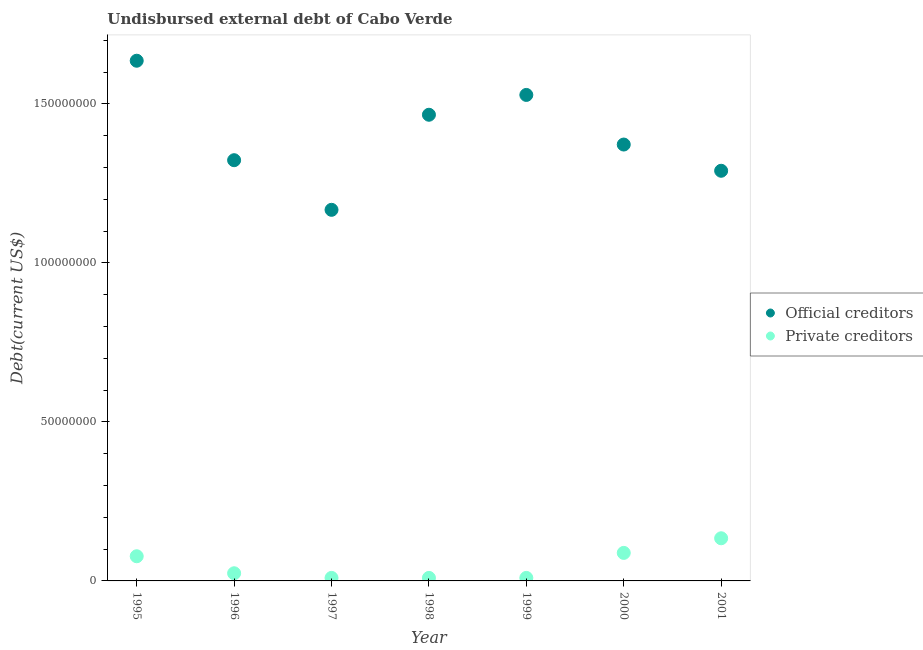How many different coloured dotlines are there?
Keep it short and to the point. 2. Is the number of dotlines equal to the number of legend labels?
Make the answer very short. Yes. What is the undisbursed external debt of official creditors in 1997?
Ensure brevity in your answer.  1.17e+08. Across all years, what is the maximum undisbursed external debt of official creditors?
Give a very brief answer. 1.64e+08. Across all years, what is the minimum undisbursed external debt of official creditors?
Offer a terse response. 1.17e+08. In which year was the undisbursed external debt of official creditors maximum?
Keep it short and to the point. 1995. What is the total undisbursed external debt of private creditors in the graph?
Your answer should be compact. 3.52e+07. What is the difference between the undisbursed external debt of official creditors in 1996 and that in 1997?
Offer a terse response. 1.56e+07. What is the difference between the undisbursed external debt of official creditors in 1997 and the undisbursed external debt of private creditors in 1996?
Your response must be concise. 1.14e+08. What is the average undisbursed external debt of official creditors per year?
Keep it short and to the point. 1.40e+08. In the year 2001, what is the difference between the undisbursed external debt of official creditors and undisbursed external debt of private creditors?
Your answer should be very brief. 1.16e+08. What is the ratio of the undisbursed external debt of official creditors in 1997 to that in 2001?
Offer a terse response. 0.9. Is the difference between the undisbursed external debt of private creditors in 1996 and 1997 greater than the difference between the undisbursed external debt of official creditors in 1996 and 1997?
Ensure brevity in your answer.  No. What is the difference between the highest and the second highest undisbursed external debt of private creditors?
Offer a very short reply. 4.60e+06. What is the difference between the highest and the lowest undisbursed external debt of private creditors?
Give a very brief answer. 1.25e+07. In how many years, is the undisbursed external debt of private creditors greater than the average undisbursed external debt of private creditors taken over all years?
Keep it short and to the point. 3. Is the sum of the undisbursed external debt of private creditors in 1999 and 2000 greater than the maximum undisbursed external debt of official creditors across all years?
Your answer should be compact. No. Does the undisbursed external debt of official creditors monotonically increase over the years?
Your response must be concise. No. Is the undisbursed external debt of official creditors strictly less than the undisbursed external debt of private creditors over the years?
Offer a very short reply. No. How many dotlines are there?
Ensure brevity in your answer.  2. How many years are there in the graph?
Offer a very short reply. 7. Are the values on the major ticks of Y-axis written in scientific E-notation?
Keep it short and to the point. No. What is the title of the graph?
Provide a short and direct response. Undisbursed external debt of Cabo Verde. What is the label or title of the Y-axis?
Keep it short and to the point. Debt(current US$). What is the Debt(current US$) in Official creditors in 1995?
Keep it short and to the point. 1.64e+08. What is the Debt(current US$) of Private creditors in 1995?
Your answer should be compact. 7.76e+06. What is the Debt(current US$) in Official creditors in 1996?
Provide a succinct answer. 1.32e+08. What is the Debt(current US$) in Private creditors in 1996?
Keep it short and to the point. 2.41e+06. What is the Debt(current US$) of Official creditors in 1997?
Your answer should be very brief. 1.17e+08. What is the Debt(current US$) of Private creditors in 1997?
Ensure brevity in your answer.  9.48e+05. What is the Debt(current US$) in Official creditors in 1998?
Offer a very short reply. 1.47e+08. What is the Debt(current US$) of Private creditors in 1998?
Your answer should be very brief. 9.48e+05. What is the Debt(current US$) of Official creditors in 1999?
Your answer should be very brief. 1.53e+08. What is the Debt(current US$) in Private creditors in 1999?
Provide a succinct answer. 9.48e+05. What is the Debt(current US$) of Official creditors in 2000?
Your answer should be very brief. 1.37e+08. What is the Debt(current US$) of Private creditors in 2000?
Ensure brevity in your answer.  8.81e+06. What is the Debt(current US$) of Official creditors in 2001?
Offer a very short reply. 1.29e+08. What is the Debt(current US$) of Private creditors in 2001?
Provide a short and direct response. 1.34e+07. Across all years, what is the maximum Debt(current US$) in Official creditors?
Ensure brevity in your answer.  1.64e+08. Across all years, what is the maximum Debt(current US$) in Private creditors?
Your answer should be very brief. 1.34e+07. Across all years, what is the minimum Debt(current US$) in Official creditors?
Your answer should be very brief. 1.17e+08. Across all years, what is the minimum Debt(current US$) in Private creditors?
Make the answer very short. 9.48e+05. What is the total Debt(current US$) of Official creditors in the graph?
Your response must be concise. 9.78e+08. What is the total Debt(current US$) of Private creditors in the graph?
Give a very brief answer. 3.52e+07. What is the difference between the Debt(current US$) of Official creditors in 1995 and that in 1996?
Offer a terse response. 3.13e+07. What is the difference between the Debt(current US$) of Private creditors in 1995 and that in 1996?
Offer a terse response. 5.35e+06. What is the difference between the Debt(current US$) of Official creditors in 1995 and that in 1997?
Ensure brevity in your answer.  4.69e+07. What is the difference between the Debt(current US$) of Private creditors in 1995 and that in 1997?
Your response must be concise. 6.81e+06. What is the difference between the Debt(current US$) of Official creditors in 1995 and that in 1998?
Offer a very short reply. 1.70e+07. What is the difference between the Debt(current US$) in Private creditors in 1995 and that in 1998?
Give a very brief answer. 6.81e+06. What is the difference between the Debt(current US$) of Official creditors in 1995 and that in 1999?
Offer a terse response. 1.08e+07. What is the difference between the Debt(current US$) of Private creditors in 1995 and that in 1999?
Provide a succinct answer. 6.81e+06. What is the difference between the Debt(current US$) of Official creditors in 1995 and that in 2000?
Offer a very short reply. 2.64e+07. What is the difference between the Debt(current US$) in Private creditors in 1995 and that in 2000?
Give a very brief answer. -1.06e+06. What is the difference between the Debt(current US$) of Official creditors in 1995 and that in 2001?
Offer a very short reply. 3.46e+07. What is the difference between the Debt(current US$) of Private creditors in 1995 and that in 2001?
Your response must be concise. -5.66e+06. What is the difference between the Debt(current US$) of Official creditors in 1996 and that in 1997?
Your answer should be very brief. 1.56e+07. What is the difference between the Debt(current US$) of Private creditors in 1996 and that in 1997?
Give a very brief answer. 1.46e+06. What is the difference between the Debt(current US$) in Official creditors in 1996 and that in 1998?
Provide a succinct answer. -1.43e+07. What is the difference between the Debt(current US$) of Private creditors in 1996 and that in 1998?
Provide a succinct answer. 1.46e+06. What is the difference between the Debt(current US$) in Official creditors in 1996 and that in 1999?
Give a very brief answer. -2.05e+07. What is the difference between the Debt(current US$) in Private creditors in 1996 and that in 1999?
Give a very brief answer. 1.46e+06. What is the difference between the Debt(current US$) in Official creditors in 1996 and that in 2000?
Offer a terse response. -4.92e+06. What is the difference between the Debt(current US$) in Private creditors in 1996 and that in 2000?
Give a very brief answer. -6.40e+06. What is the difference between the Debt(current US$) in Official creditors in 1996 and that in 2001?
Your response must be concise. 3.32e+06. What is the difference between the Debt(current US$) in Private creditors in 1996 and that in 2001?
Your response must be concise. -1.10e+07. What is the difference between the Debt(current US$) in Official creditors in 1997 and that in 1998?
Offer a very short reply. -2.99e+07. What is the difference between the Debt(current US$) of Private creditors in 1997 and that in 1998?
Your answer should be compact. 0. What is the difference between the Debt(current US$) of Official creditors in 1997 and that in 1999?
Ensure brevity in your answer.  -3.61e+07. What is the difference between the Debt(current US$) of Official creditors in 1997 and that in 2000?
Make the answer very short. -2.05e+07. What is the difference between the Debt(current US$) of Private creditors in 1997 and that in 2000?
Offer a very short reply. -7.86e+06. What is the difference between the Debt(current US$) of Official creditors in 1997 and that in 2001?
Provide a short and direct response. -1.23e+07. What is the difference between the Debt(current US$) of Private creditors in 1997 and that in 2001?
Offer a very short reply. -1.25e+07. What is the difference between the Debt(current US$) of Official creditors in 1998 and that in 1999?
Your answer should be compact. -6.23e+06. What is the difference between the Debt(current US$) in Official creditors in 1998 and that in 2000?
Offer a very short reply. 9.37e+06. What is the difference between the Debt(current US$) of Private creditors in 1998 and that in 2000?
Give a very brief answer. -7.86e+06. What is the difference between the Debt(current US$) of Official creditors in 1998 and that in 2001?
Your answer should be compact. 1.76e+07. What is the difference between the Debt(current US$) of Private creditors in 1998 and that in 2001?
Keep it short and to the point. -1.25e+07. What is the difference between the Debt(current US$) in Official creditors in 1999 and that in 2000?
Keep it short and to the point. 1.56e+07. What is the difference between the Debt(current US$) in Private creditors in 1999 and that in 2000?
Keep it short and to the point. -7.86e+06. What is the difference between the Debt(current US$) in Official creditors in 1999 and that in 2001?
Ensure brevity in your answer.  2.38e+07. What is the difference between the Debt(current US$) of Private creditors in 1999 and that in 2001?
Provide a short and direct response. -1.25e+07. What is the difference between the Debt(current US$) in Official creditors in 2000 and that in 2001?
Keep it short and to the point. 8.25e+06. What is the difference between the Debt(current US$) of Private creditors in 2000 and that in 2001?
Keep it short and to the point. -4.60e+06. What is the difference between the Debt(current US$) in Official creditors in 1995 and the Debt(current US$) in Private creditors in 1996?
Keep it short and to the point. 1.61e+08. What is the difference between the Debt(current US$) in Official creditors in 1995 and the Debt(current US$) in Private creditors in 1997?
Make the answer very short. 1.63e+08. What is the difference between the Debt(current US$) in Official creditors in 1995 and the Debt(current US$) in Private creditors in 1998?
Make the answer very short. 1.63e+08. What is the difference between the Debt(current US$) in Official creditors in 1995 and the Debt(current US$) in Private creditors in 1999?
Keep it short and to the point. 1.63e+08. What is the difference between the Debt(current US$) of Official creditors in 1995 and the Debt(current US$) of Private creditors in 2000?
Ensure brevity in your answer.  1.55e+08. What is the difference between the Debt(current US$) of Official creditors in 1995 and the Debt(current US$) of Private creditors in 2001?
Provide a short and direct response. 1.50e+08. What is the difference between the Debt(current US$) of Official creditors in 1996 and the Debt(current US$) of Private creditors in 1997?
Ensure brevity in your answer.  1.31e+08. What is the difference between the Debt(current US$) in Official creditors in 1996 and the Debt(current US$) in Private creditors in 1998?
Offer a terse response. 1.31e+08. What is the difference between the Debt(current US$) in Official creditors in 1996 and the Debt(current US$) in Private creditors in 1999?
Offer a very short reply. 1.31e+08. What is the difference between the Debt(current US$) of Official creditors in 1996 and the Debt(current US$) of Private creditors in 2000?
Your response must be concise. 1.23e+08. What is the difference between the Debt(current US$) in Official creditors in 1996 and the Debt(current US$) in Private creditors in 2001?
Make the answer very short. 1.19e+08. What is the difference between the Debt(current US$) in Official creditors in 1997 and the Debt(current US$) in Private creditors in 1998?
Offer a very short reply. 1.16e+08. What is the difference between the Debt(current US$) in Official creditors in 1997 and the Debt(current US$) in Private creditors in 1999?
Offer a very short reply. 1.16e+08. What is the difference between the Debt(current US$) of Official creditors in 1997 and the Debt(current US$) of Private creditors in 2000?
Your answer should be very brief. 1.08e+08. What is the difference between the Debt(current US$) of Official creditors in 1997 and the Debt(current US$) of Private creditors in 2001?
Keep it short and to the point. 1.03e+08. What is the difference between the Debt(current US$) of Official creditors in 1998 and the Debt(current US$) of Private creditors in 1999?
Provide a short and direct response. 1.46e+08. What is the difference between the Debt(current US$) of Official creditors in 1998 and the Debt(current US$) of Private creditors in 2000?
Keep it short and to the point. 1.38e+08. What is the difference between the Debt(current US$) of Official creditors in 1998 and the Debt(current US$) of Private creditors in 2001?
Provide a succinct answer. 1.33e+08. What is the difference between the Debt(current US$) in Official creditors in 1999 and the Debt(current US$) in Private creditors in 2000?
Your answer should be very brief. 1.44e+08. What is the difference between the Debt(current US$) in Official creditors in 1999 and the Debt(current US$) in Private creditors in 2001?
Offer a terse response. 1.39e+08. What is the difference between the Debt(current US$) of Official creditors in 2000 and the Debt(current US$) of Private creditors in 2001?
Give a very brief answer. 1.24e+08. What is the average Debt(current US$) of Official creditors per year?
Offer a very short reply. 1.40e+08. What is the average Debt(current US$) of Private creditors per year?
Provide a succinct answer. 5.03e+06. In the year 1995, what is the difference between the Debt(current US$) of Official creditors and Debt(current US$) of Private creditors?
Offer a very short reply. 1.56e+08. In the year 1996, what is the difference between the Debt(current US$) in Official creditors and Debt(current US$) in Private creditors?
Provide a succinct answer. 1.30e+08. In the year 1997, what is the difference between the Debt(current US$) in Official creditors and Debt(current US$) in Private creditors?
Provide a succinct answer. 1.16e+08. In the year 1998, what is the difference between the Debt(current US$) in Official creditors and Debt(current US$) in Private creditors?
Ensure brevity in your answer.  1.46e+08. In the year 1999, what is the difference between the Debt(current US$) in Official creditors and Debt(current US$) in Private creditors?
Your response must be concise. 1.52e+08. In the year 2000, what is the difference between the Debt(current US$) of Official creditors and Debt(current US$) of Private creditors?
Your answer should be compact. 1.28e+08. In the year 2001, what is the difference between the Debt(current US$) of Official creditors and Debt(current US$) of Private creditors?
Your answer should be compact. 1.16e+08. What is the ratio of the Debt(current US$) in Official creditors in 1995 to that in 1996?
Offer a terse response. 1.24. What is the ratio of the Debt(current US$) of Private creditors in 1995 to that in 1996?
Make the answer very short. 3.22. What is the ratio of the Debt(current US$) of Official creditors in 1995 to that in 1997?
Give a very brief answer. 1.4. What is the ratio of the Debt(current US$) of Private creditors in 1995 to that in 1997?
Keep it short and to the point. 8.18. What is the ratio of the Debt(current US$) in Official creditors in 1995 to that in 1998?
Offer a terse response. 1.12. What is the ratio of the Debt(current US$) in Private creditors in 1995 to that in 1998?
Your response must be concise. 8.18. What is the ratio of the Debt(current US$) of Official creditors in 1995 to that in 1999?
Keep it short and to the point. 1.07. What is the ratio of the Debt(current US$) in Private creditors in 1995 to that in 1999?
Give a very brief answer. 8.18. What is the ratio of the Debt(current US$) in Official creditors in 1995 to that in 2000?
Provide a succinct answer. 1.19. What is the ratio of the Debt(current US$) in Private creditors in 1995 to that in 2000?
Your response must be concise. 0.88. What is the ratio of the Debt(current US$) of Official creditors in 1995 to that in 2001?
Offer a terse response. 1.27. What is the ratio of the Debt(current US$) of Private creditors in 1995 to that in 2001?
Offer a terse response. 0.58. What is the ratio of the Debt(current US$) in Official creditors in 1996 to that in 1997?
Your answer should be compact. 1.13. What is the ratio of the Debt(current US$) in Private creditors in 1996 to that in 1997?
Your response must be concise. 2.54. What is the ratio of the Debt(current US$) in Official creditors in 1996 to that in 1998?
Ensure brevity in your answer.  0.9. What is the ratio of the Debt(current US$) of Private creditors in 1996 to that in 1998?
Your response must be concise. 2.54. What is the ratio of the Debt(current US$) in Official creditors in 1996 to that in 1999?
Ensure brevity in your answer.  0.87. What is the ratio of the Debt(current US$) in Private creditors in 1996 to that in 1999?
Provide a short and direct response. 2.54. What is the ratio of the Debt(current US$) of Official creditors in 1996 to that in 2000?
Keep it short and to the point. 0.96. What is the ratio of the Debt(current US$) in Private creditors in 1996 to that in 2000?
Provide a succinct answer. 0.27. What is the ratio of the Debt(current US$) of Official creditors in 1996 to that in 2001?
Your answer should be compact. 1.03. What is the ratio of the Debt(current US$) in Private creditors in 1996 to that in 2001?
Keep it short and to the point. 0.18. What is the ratio of the Debt(current US$) of Official creditors in 1997 to that in 1998?
Offer a very short reply. 0.8. What is the ratio of the Debt(current US$) in Official creditors in 1997 to that in 1999?
Offer a terse response. 0.76. What is the ratio of the Debt(current US$) in Official creditors in 1997 to that in 2000?
Give a very brief answer. 0.85. What is the ratio of the Debt(current US$) of Private creditors in 1997 to that in 2000?
Offer a very short reply. 0.11. What is the ratio of the Debt(current US$) of Official creditors in 1997 to that in 2001?
Give a very brief answer. 0.9. What is the ratio of the Debt(current US$) of Private creditors in 1997 to that in 2001?
Make the answer very short. 0.07. What is the ratio of the Debt(current US$) of Official creditors in 1998 to that in 1999?
Give a very brief answer. 0.96. What is the ratio of the Debt(current US$) in Private creditors in 1998 to that in 1999?
Make the answer very short. 1. What is the ratio of the Debt(current US$) in Official creditors in 1998 to that in 2000?
Ensure brevity in your answer.  1.07. What is the ratio of the Debt(current US$) of Private creditors in 1998 to that in 2000?
Your response must be concise. 0.11. What is the ratio of the Debt(current US$) of Official creditors in 1998 to that in 2001?
Your answer should be very brief. 1.14. What is the ratio of the Debt(current US$) of Private creditors in 1998 to that in 2001?
Provide a short and direct response. 0.07. What is the ratio of the Debt(current US$) in Official creditors in 1999 to that in 2000?
Provide a short and direct response. 1.11. What is the ratio of the Debt(current US$) of Private creditors in 1999 to that in 2000?
Keep it short and to the point. 0.11. What is the ratio of the Debt(current US$) of Official creditors in 1999 to that in 2001?
Provide a short and direct response. 1.18. What is the ratio of the Debt(current US$) in Private creditors in 1999 to that in 2001?
Offer a terse response. 0.07. What is the ratio of the Debt(current US$) in Official creditors in 2000 to that in 2001?
Your response must be concise. 1.06. What is the ratio of the Debt(current US$) of Private creditors in 2000 to that in 2001?
Your response must be concise. 0.66. What is the difference between the highest and the second highest Debt(current US$) in Official creditors?
Offer a very short reply. 1.08e+07. What is the difference between the highest and the second highest Debt(current US$) in Private creditors?
Keep it short and to the point. 4.60e+06. What is the difference between the highest and the lowest Debt(current US$) of Official creditors?
Offer a very short reply. 4.69e+07. What is the difference between the highest and the lowest Debt(current US$) of Private creditors?
Offer a very short reply. 1.25e+07. 